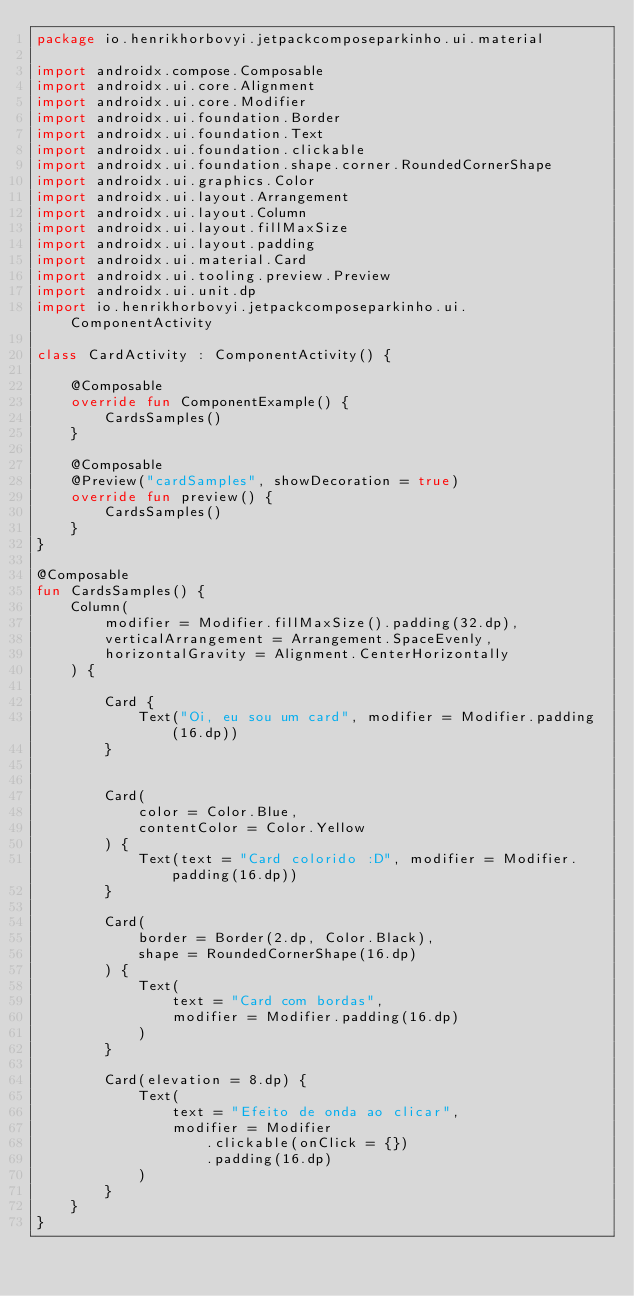<code> <loc_0><loc_0><loc_500><loc_500><_Kotlin_>package io.henrikhorbovyi.jetpackcomposeparkinho.ui.material

import androidx.compose.Composable
import androidx.ui.core.Alignment
import androidx.ui.core.Modifier
import androidx.ui.foundation.Border
import androidx.ui.foundation.Text
import androidx.ui.foundation.clickable
import androidx.ui.foundation.shape.corner.RoundedCornerShape
import androidx.ui.graphics.Color
import androidx.ui.layout.Arrangement
import androidx.ui.layout.Column
import androidx.ui.layout.fillMaxSize
import androidx.ui.layout.padding
import androidx.ui.material.Card
import androidx.ui.tooling.preview.Preview
import androidx.ui.unit.dp
import io.henrikhorbovyi.jetpackcomposeparkinho.ui.ComponentActivity

class CardActivity : ComponentActivity() {

    @Composable
    override fun ComponentExample() {
        CardsSamples()
    }

    @Composable
    @Preview("cardSamples", showDecoration = true)
    override fun preview() {
        CardsSamples()
    }
}

@Composable
fun CardsSamples() {
    Column(
        modifier = Modifier.fillMaxSize().padding(32.dp),
        verticalArrangement = Arrangement.SpaceEvenly,
        horizontalGravity = Alignment.CenterHorizontally
    ) {

        Card {
            Text("Oi, eu sou um card", modifier = Modifier.padding(16.dp))
        }


        Card(
            color = Color.Blue,
            contentColor = Color.Yellow
        ) {
            Text(text = "Card colorido :D", modifier = Modifier.padding(16.dp))
        }

        Card(
            border = Border(2.dp, Color.Black),
            shape = RoundedCornerShape(16.dp)
        ) {
            Text(
                text = "Card com bordas",
                modifier = Modifier.padding(16.dp)
            )
        }

        Card(elevation = 8.dp) {
            Text(
                text = "Efeito de onda ao clicar",
                modifier = Modifier
                    .clickable(onClick = {})
                    .padding(16.dp)
            )
        }
    }
}</code> 